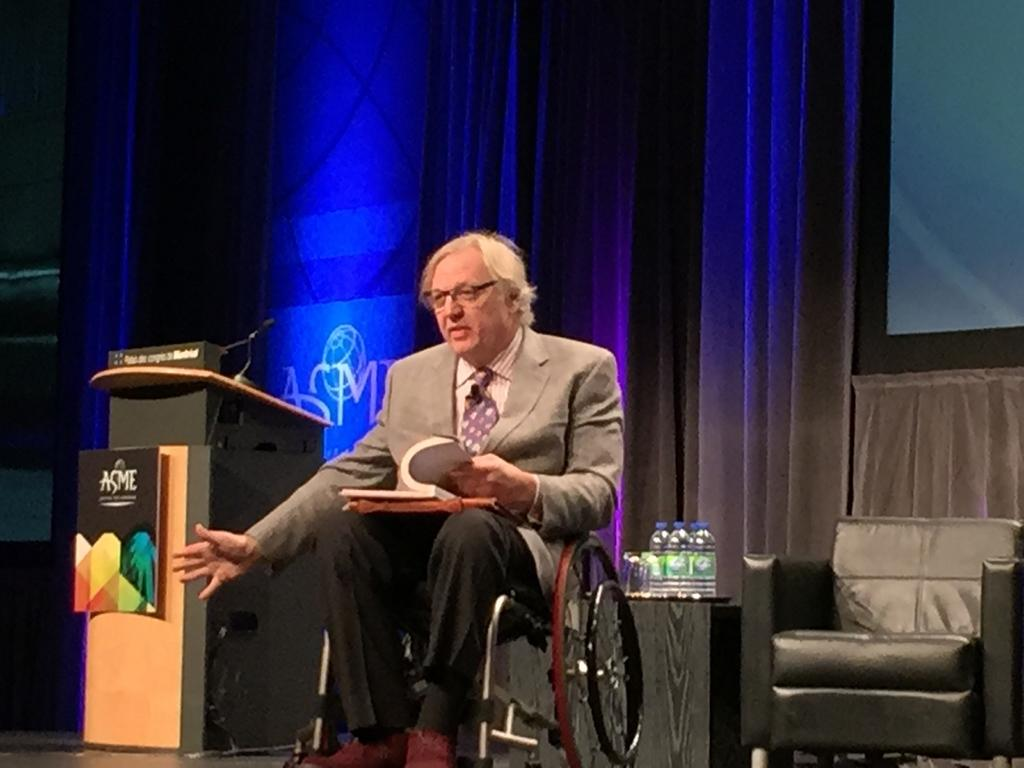What is the man in the image doing? The man is sitting on a wheelchair in the image. What is the man holding in his hand? The man is holding a book in his hand. What can be seen near the man in the image? There is a podium and a microphone in the image. What else is present in the image? There are bottles and a chair in the image. What type of steel is used to construct the snails in the image? There are no snails present in the image, and therefore no steel construction can be observed. How many cattle can be seen grazing in the image? There are no cattle present in the image. 